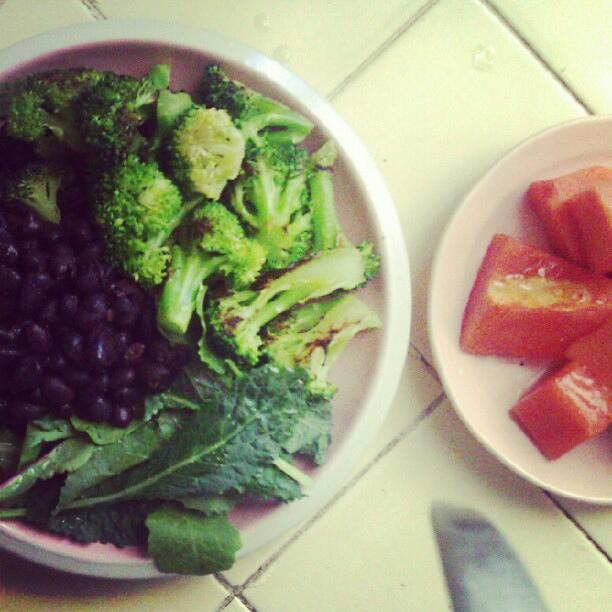Which item is likely most crispy? broccoli 